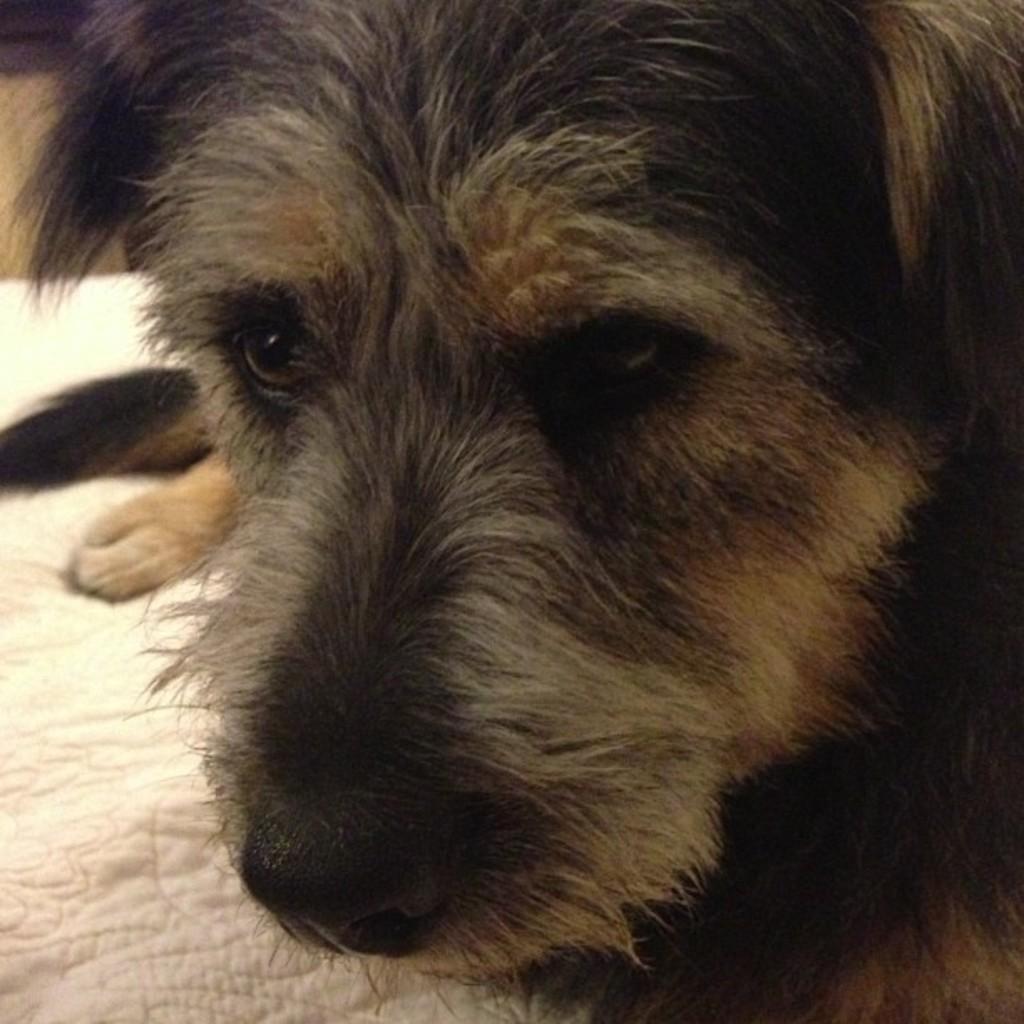Could you give a brief overview of what you see in this image? We can see dog on cloth. 